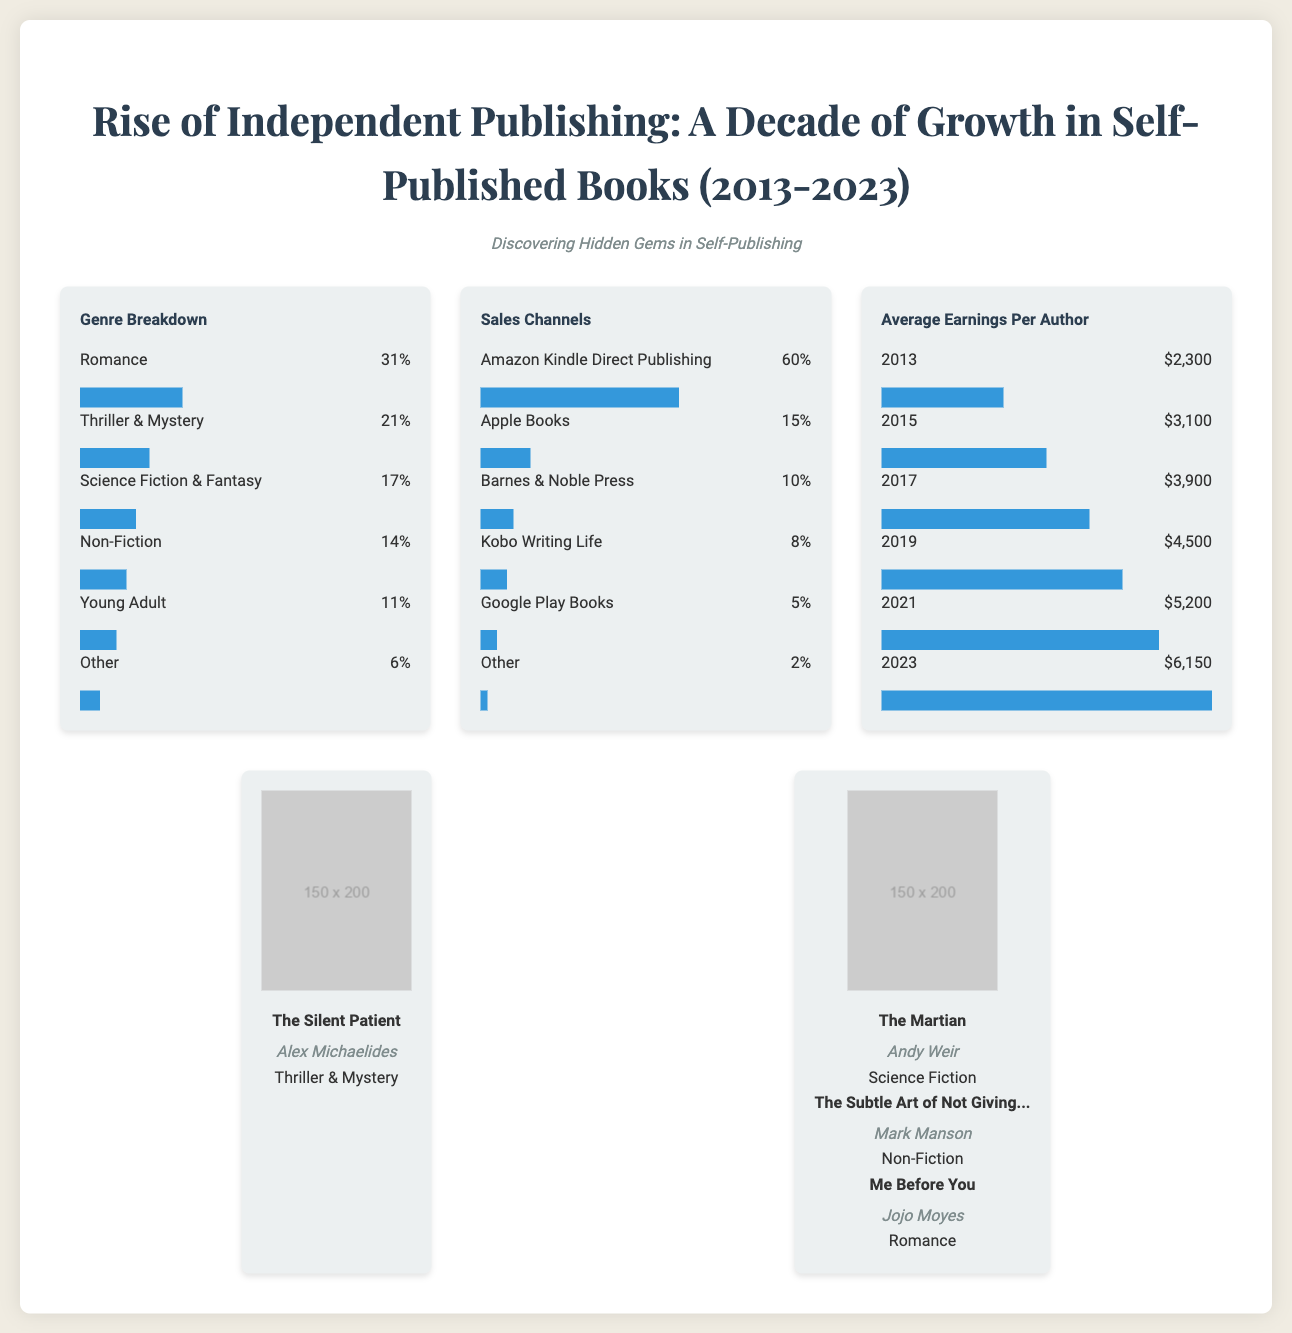what genre has the highest percentage of self-published books? The genre with the highest percentage is indicated in the Genre Breakdown section, which shows Romance at 31%.
Answer: Romance what percentage of self-published books fall under the "Other" category? The percentage for the "Other" category is stated in the Genre Breakdown section, which is 6%.
Answer: 6% which sales channel dominates self-publishing? The dominant sales channel is highlighted in the Sales Channels section, showing that Amazon Kindle Direct Publishing accounts for 60%.
Answer: Amazon Kindle Direct Publishing what was the average earnings per author in 2021? The average earnings specifically for 2021 is provided in the Average Earnings Per Author section, which shows $5,200.
Answer: $5,200 which genre has the lowest representation in self-published books? The genre with the lowest representation is given in the Genre Breakdown, which is "Other" at 6%.
Answer: Other what was the average earnings per author in the year 2013? The document states that the average earnings per author in 2013 is $2,300 according to the chart.
Answer: $2,300 how much of the self-publishing market does Apple Books represent? The percentage for Apple Books is mentioned in the Sales Channels section, which is 15%.
Answer: 15% what is the percentage increase in average earnings from 2013 to 2023? The increase can be calculated from the Average Earnings Per Author section, which shows an increase from $2,300 in 2013 to $6,150 in 2023.
Answer: $3,850 which book cover is illustrated for a thriller genre? The document displays "The Silent Patient" by Alex Michaelides as a thriller in the illustrations section.
Answer: The Silent Patient 